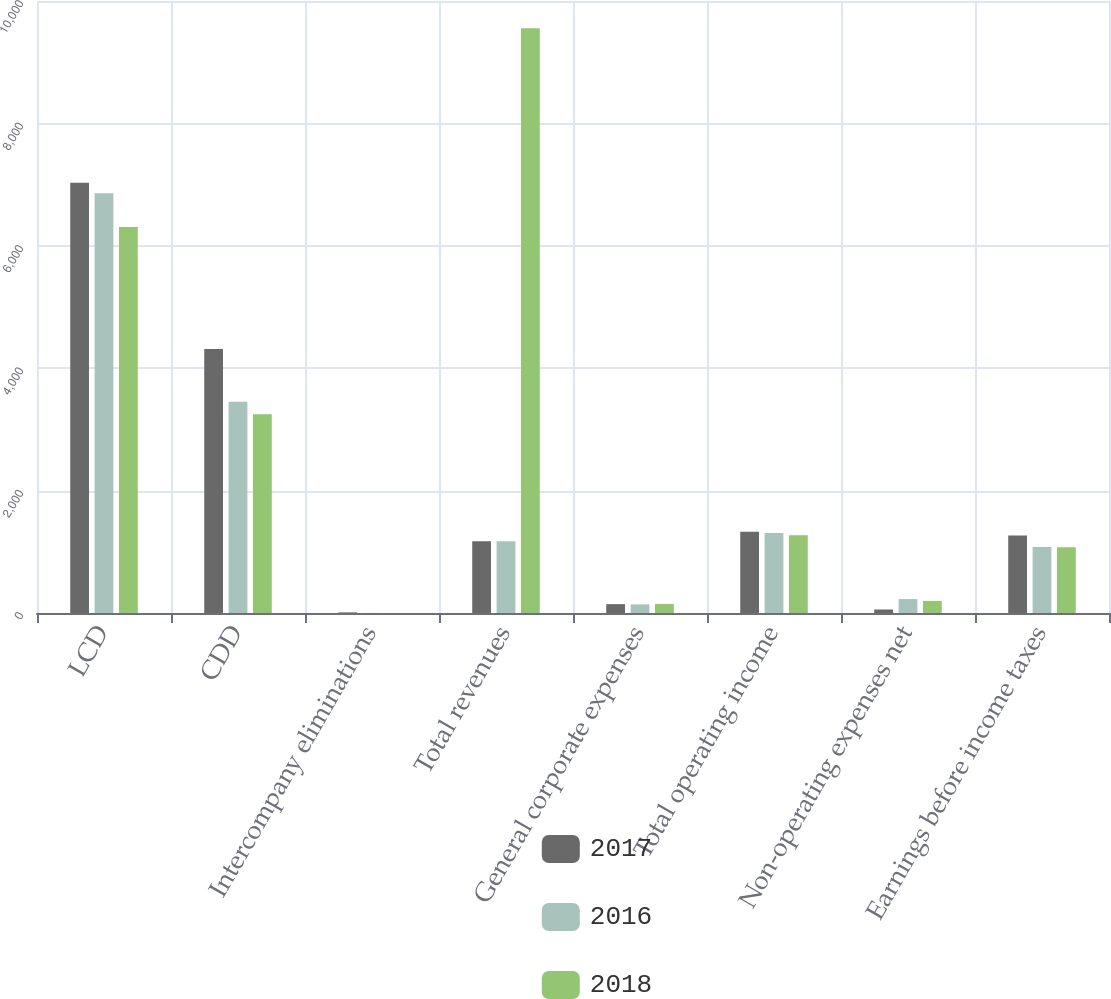Convert chart. <chart><loc_0><loc_0><loc_500><loc_500><stacked_bar_chart><ecel><fcel>LCD<fcel>CDD<fcel>Intercompany eliminations<fcel>Total revenues<fcel>General corporate expenses<fcel>Total operating income<fcel>Non-operating expenses net<fcel>Earnings before income taxes<nl><fcel>2017<fcel>7030.8<fcel>4313.1<fcel>10.5<fcel>1172.9<fcel>144.6<fcel>1325.7<fcel>57.4<fcel>1268.3<nl><fcel>2016<fcel>6858.2<fcel>3451.6<fcel>1.8<fcel>1172.9<fcel>140.6<fcel>1305.2<fcel>227.7<fcel>1077.5<nl><fcel>2018<fcel>6307.6<fcel>3245.8<fcel>0.5<fcel>9552.9<fcel>147.9<fcel>1270.6<fcel>197<fcel>1073.6<nl></chart> 